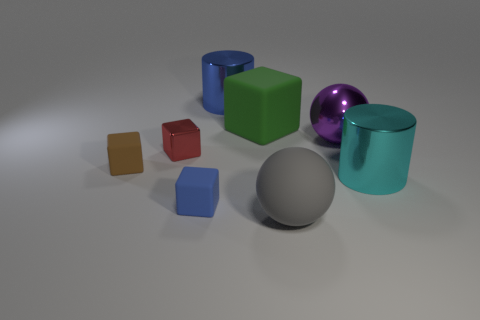Add 1 tiny cyan metallic cylinders. How many objects exist? 9 Subtract all cylinders. How many objects are left? 6 Add 1 blue matte cubes. How many blue matte cubes are left? 2 Add 2 red things. How many red things exist? 3 Subtract 0 yellow cylinders. How many objects are left? 8 Subtract all small cyan cylinders. Subtract all purple metal objects. How many objects are left? 7 